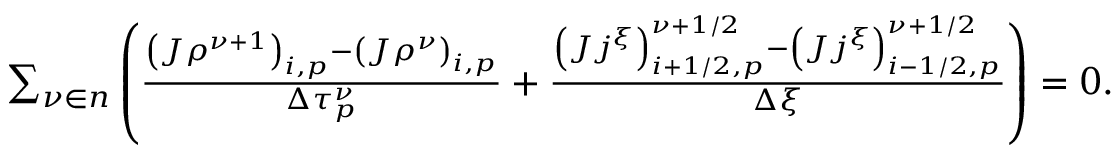Convert formula to latex. <formula><loc_0><loc_0><loc_500><loc_500>\begin{array} { r } { \sum _ { \nu \in n } \left ( \frac { \left ( J \rho ^ { \nu + 1 } \right ) _ { i , p } - \left ( J \rho ^ { \nu } \right ) _ { i , p } } { \Delta \tau _ { p } ^ { \nu } } + \frac { \left ( J j ^ { \xi } \right ) _ { i + 1 / 2 , p } ^ { \nu + 1 / 2 } - \left ( J j ^ { \xi } \right ) _ { i - 1 / 2 , p } ^ { \nu + 1 / 2 } } { \Delta \xi } \right ) = 0 . } \end{array}</formula> 